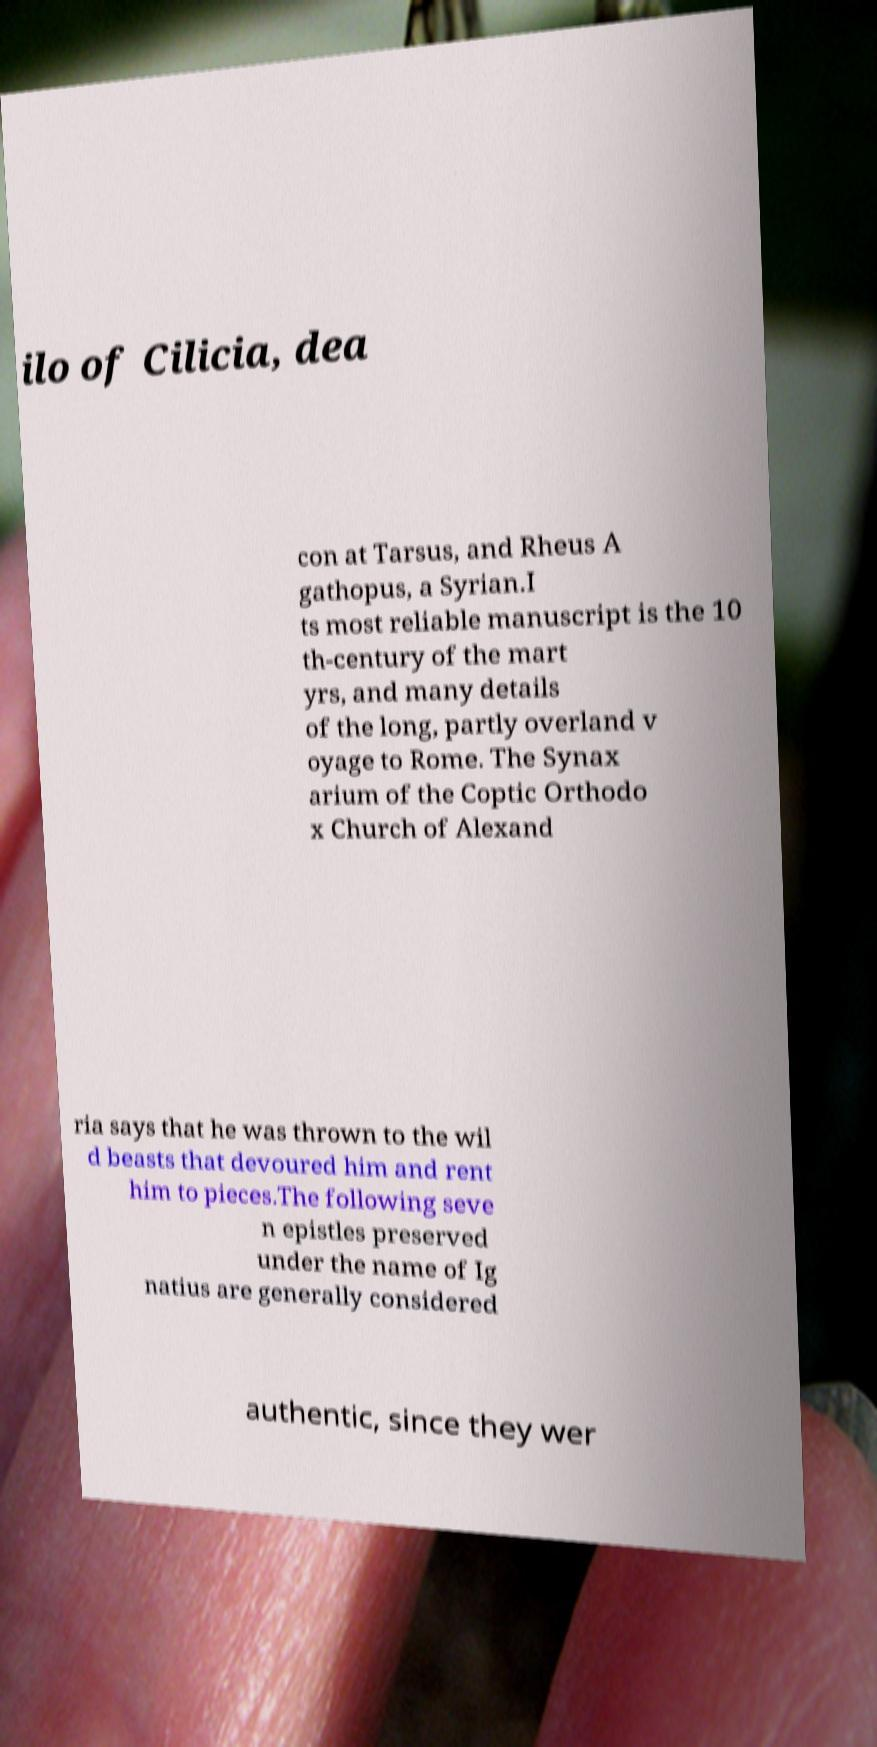Can you accurately transcribe the text from the provided image for me? ilo of Cilicia, dea con at Tarsus, and Rheus A gathopus, a Syrian.I ts most reliable manuscript is the 10 th-century of the mart yrs, and many details of the long, partly overland v oyage to Rome. The Synax arium of the Coptic Orthodo x Church of Alexand ria says that he was thrown to the wil d beasts that devoured him and rent him to pieces.The following seve n epistles preserved under the name of Ig natius are generally considered authentic, since they wer 